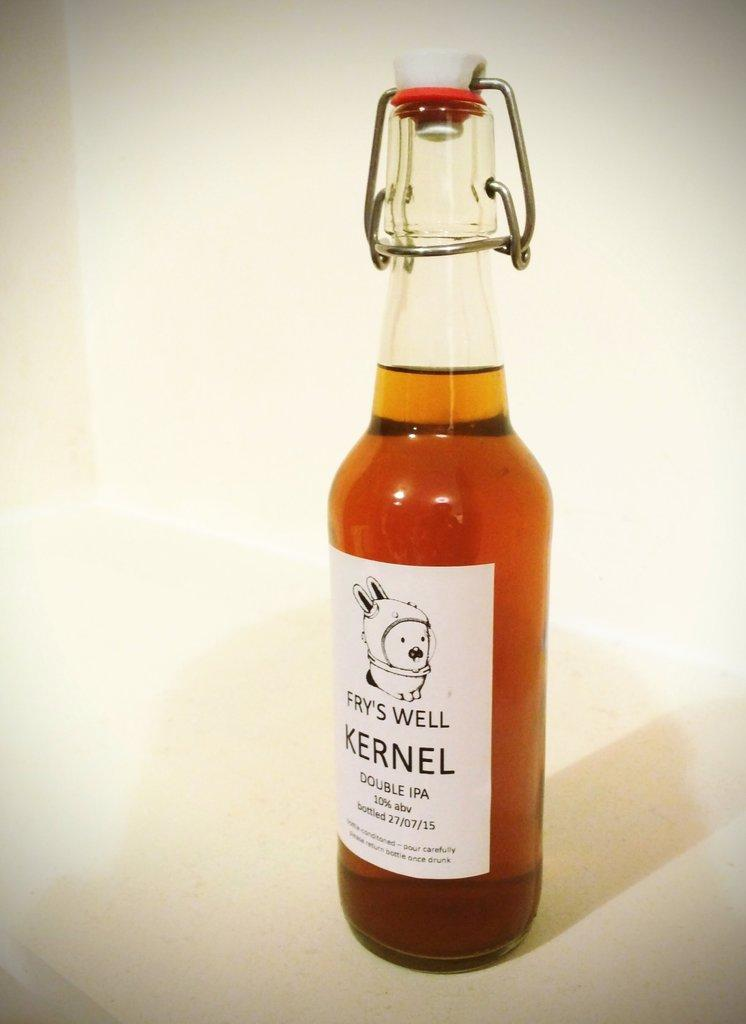Provide a one-sentence caption for the provided image. a bottle has the word kernel on it. 